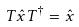<formula> <loc_0><loc_0><loc_500><loc_500>T \hat { x } T ^ { \dagger } = \hat { x }</formula> 